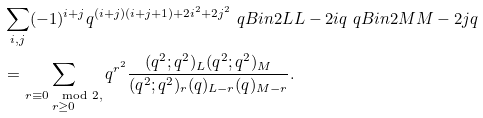Convert formula to latex. <formula><loc_0><loc_0><loc_500><loc_500>& \sum _ { i , j } ( - 1 ) ^ { i + j } q ^ { ( i + j ) ( i + j + 1 ) + 2 i ^ { 2 } + 2 j ^ { 2 } } \ q B i n { 2 L } { L - 2 i } { q } \ q B i n { 2 M } { M - 2 j } { q } \\ & = \sum _ { \substack { r \equiv 0 \mod 2 , \\ r \geq 0 } } q ^ { r ^ { 2 } } \frac { ( q ^ { 2 } ; q ^ { 2 } ) _ { L } ( q ^ { 2 } ; q ^ { 2 } ) _ { M } } { ( q ^ { 2 } ; q ^ { 2 } ) _ { r } ( q ) _ { L - r } ( q ) _ { M - r } } .</formula> 